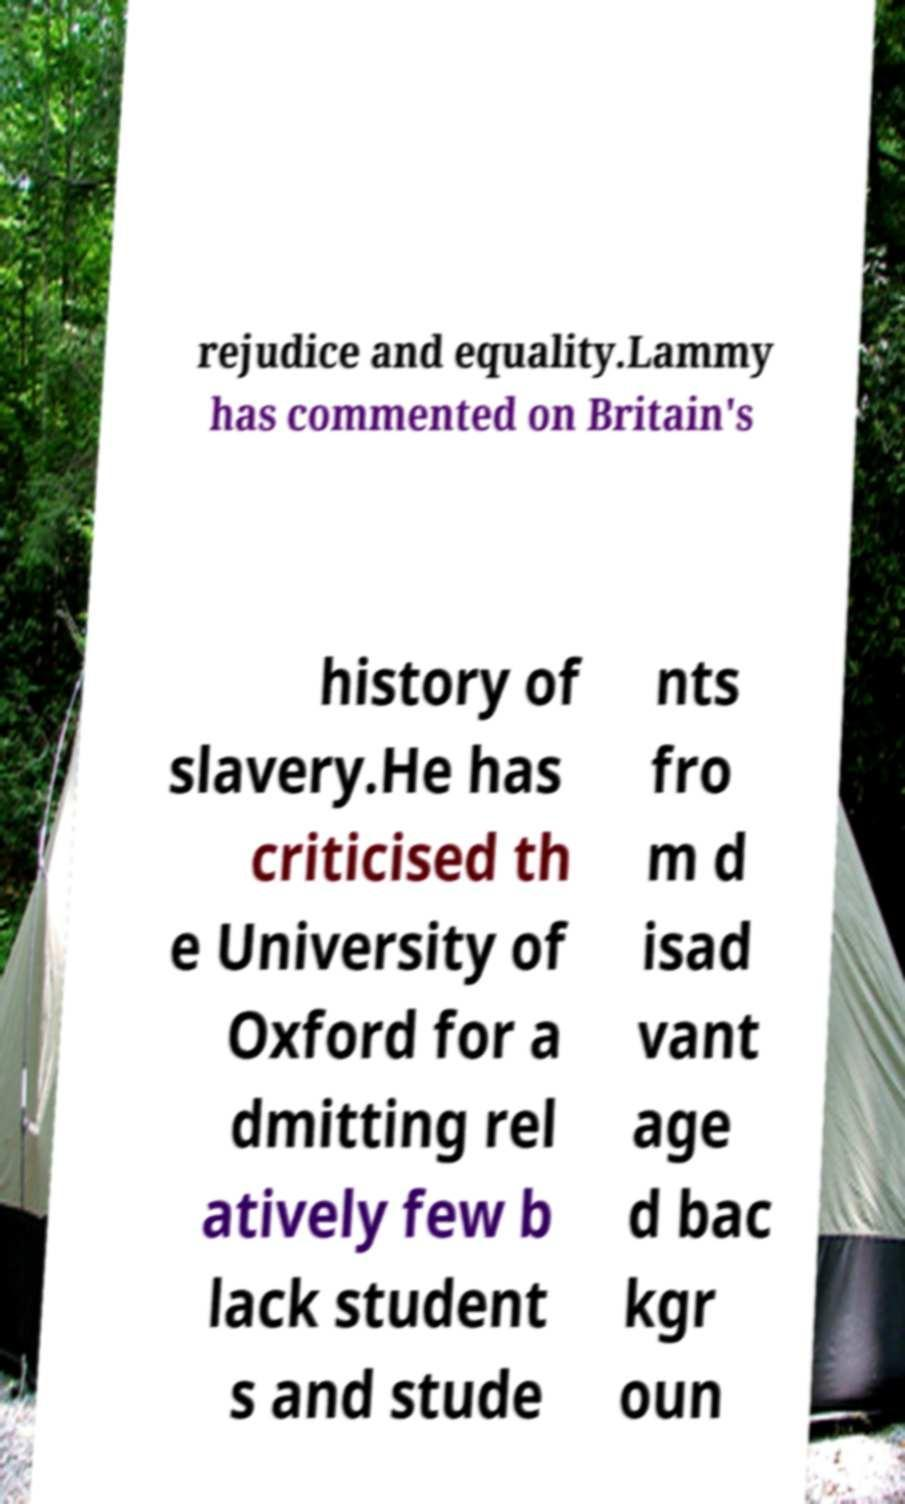Can you read and provide the text displayed in the image?This photo seems to have some interesting text. Can you extract and type it out for me? rejudice and equality.Lammy has commented on Britain's history of slavery.He has criticised th e University of Oxford for a dmitting rel atively few b lack student s and stude nts fro m d isad vant age d bac kgr oun 